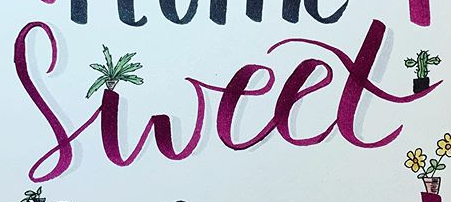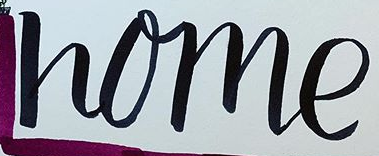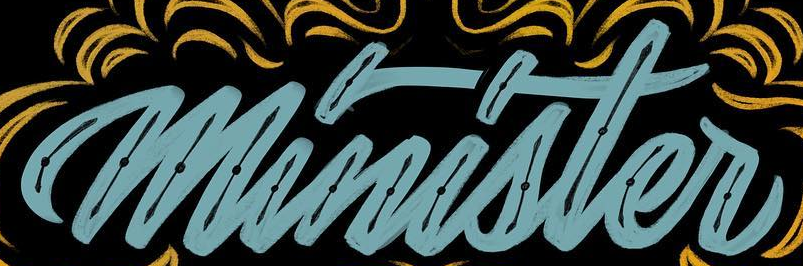Identify the words shown in these images in order, separated by a semicolon. sweet; home; minister 